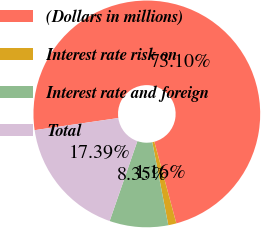Convert chart. <chart><loc_0><loc_0><loc_500><loc_500><pie_chart><fcel>(Dollars in millions)<fcel>Interest rate risk on<fcel>Interest rate and foreign<fcel>Total<nl><fcel>73.09%<fcel>1.16%<fcel>8.35%<fcel>17.39%<nl></chart> 